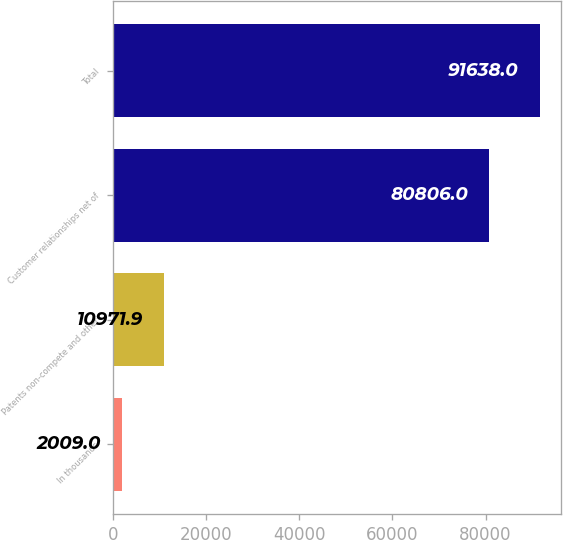Convert chart to OTSL. <chart><loc_0><loc_0><loc_500><loc_500><bar_chart><fcel>In thousands<fcel>Patents non-compete and other<fcel>Customer relationships net of<fcel>Total<nl><fcel>2009<fcel>10971.9<fcel>80806<fcel>91638<nl></chart> 